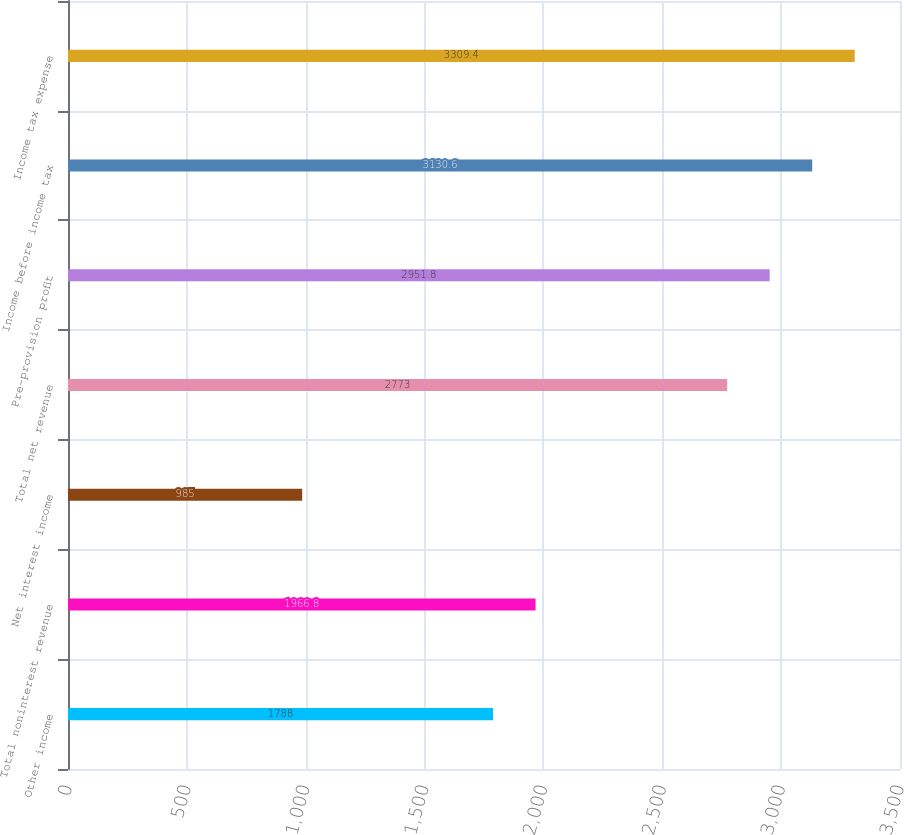<chart> <loc_0><loc_0><loc_500><loc_500><bar_chart><fcel>Other income<fcel>Total noninterest revenue<fcel>Net interest income<fcel>Total net revenue<fcel>Pre-provision profit<fcel>Income before income tax<fcel>Income tax expense<nl><fcel>1788<fcel>1966.8<fcel>985<fcel>2773<fcel>2951.8<fcel>3130.6<fcel>3309.4<nl></chart> 